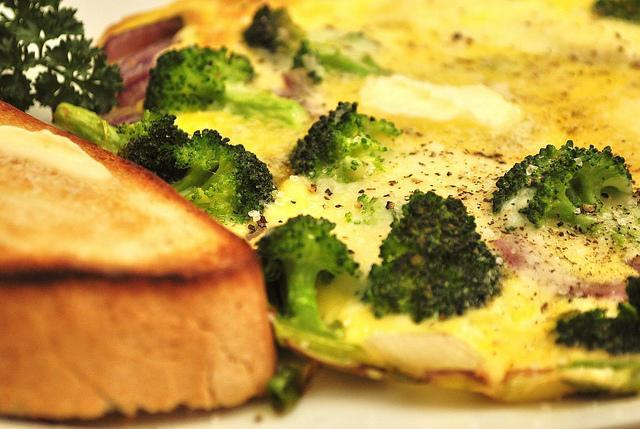How many broccolis are visible?
Give a very brief answer. 8. How many bears are there?
Give a very brief answer. 0. 